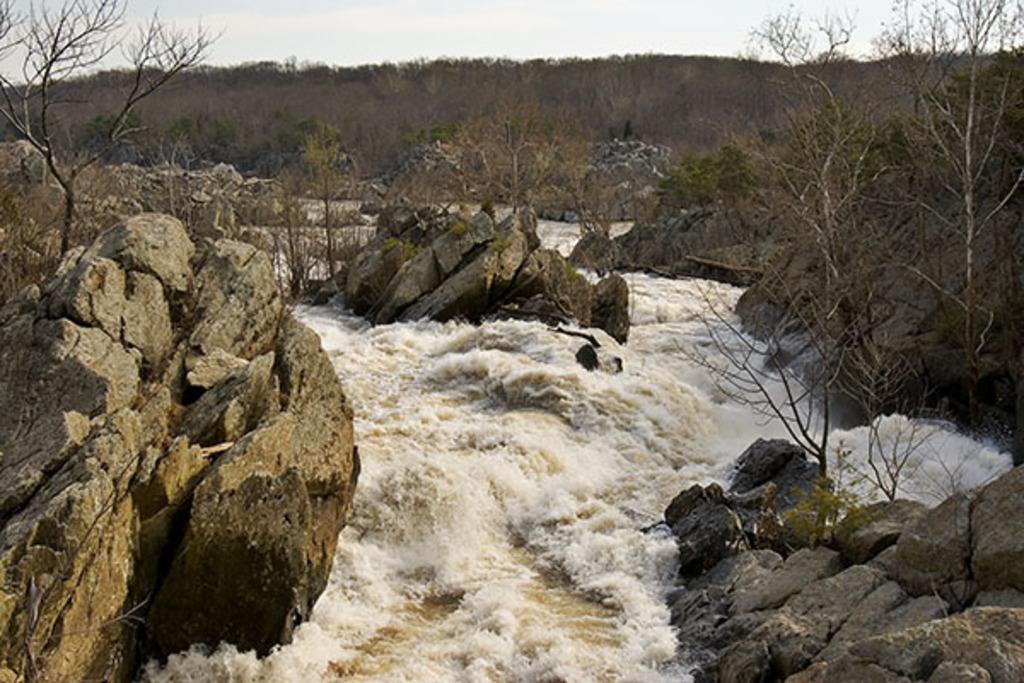Please provide a concise description of this image. In this image, we can see water flow, rocks and plants. Background we can see trees and sky. 